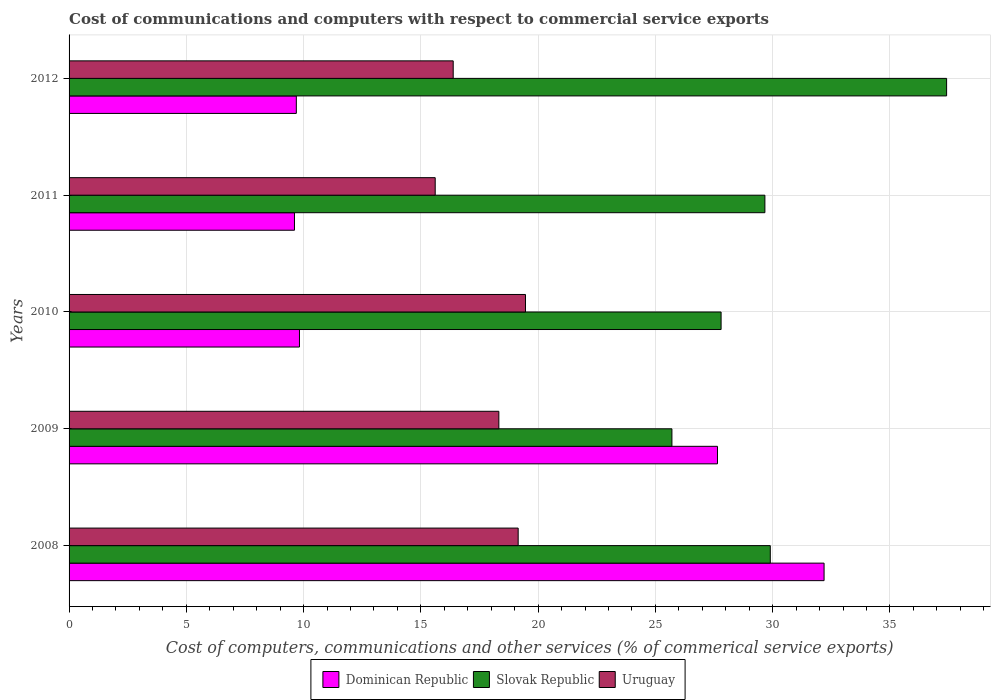In how many cases, is the number of bars for a given year not equal to the number of legend labels?
Ensure brevity in your answer.  0. What is the cost of communications and computers in Slovak Republic in 2009?
Your answer should be very brief. 25.71. Across all years, what is the maximum cost of communications and computers in Slovak Republic?
Give a very brief answer. 37.42. Across all years, what is the minimum cost of communications and computers in Dominican Republic?
Offer a terse response. 9.61. What is the total cost of communications and computers in Uruguay in the graph?
Offer a very short reply. 88.93. What is the difference between the cost of communications and computers in Slovak Republic in 2009 and that in 2011?
Give a very brief answer. -3.96. What is the difference between the cost of communications and computers in Dominican Republic in 2011 and the cost of communications and computers in Uruguay in 2012?
Provide a succinct answer. -6.77. What is the average cost of communications and computers in Dominican Republic per year?
Ensure brevity in your answer.  17.79. In the year 2012, what is the difference between the cost of communications and computers in Dominican Republic and cost of communications and computers in Uruguay?
Provide a succinct answer. -6.69. What is the ratio of the cost of communications and computers in Slovak Republic in 2009 to that in 2011?
Offer a very short reply. 0.87. What is the difference between the highest and the second highest cost of communications and computers in Dominican Republic?
Offer a terse response. 4.55. What is the difference between the highest and the lowest cost of communications and computers in Dominican Republic?
Offer a very short reply. 22.58. Is the sum of the cost of communications and computers in Dominican Republic in 2009 and 2010 greater than the maximum cost of communications and computers in Slovak Republic across all years?
Your answer should be very brief. Yes. What does the 3rd bar from the top in 2010 represents?
Keep it short and to the point. Dominican Republic. What does the 3rd bar from the bottom in 2008 represents?
Your answer should be very brief. Uruguay. Are all the bars in the graph horizontal?
Make the answer very short. Yes. How many years are there in the graph?
Your answer should be compact. 5. What is the difference between two consecutive major ticks on the X-axis?
Ensure brevity in your answer.  5. Are the values on the major ticks of X-axis written in scientific E-notation?
Offer a very short reply. No. Does the graph contain grids?
Give a very brief answer. Yes. How many legend labels are there?
Ensure brevity in your answer.  3. What is the title of the graph?
Give a very brief answer. Cost of communications and computers with respect to commercial service exports. Does "Brazil" appear as one of the legend labels in the graph?
Your answer should be compact. No. What is the label or title of the X-axis?
Offer a terse response. Cost of computers, communications and other services (% of commerical service exports). What is the Cost of computers, communications and other services (% of commerical service exports) of Dominican Republic in 2008?
Your answer should be compact. 32.19. What is the Cost of computers, communications and other services (% of commerical service exports) of Slovak Republic in 2008?
Offer a very short reply. 29.9. What is the Cost of computers, communications and other services (% of commerical service exports) in Uruguay in 2008?
Provide a succinct answer. 19.15. What is the Cost of computers, communications and other services (% of commerical service exports) of Dominican Republic in 2009?
Ensure brevity in your answer.  27.65. What is the Cost of computers, communications and other services (% of commerical service exports) of Slovak Republic in 2009?
Your answer should be very brief. 25.71. What is the Cost of computers, communications and other services (% of commerical service exports) in Uruguay in 2009?
Your answer should be compact. 18.33. What is the Cost of computers, communications and other services (% of commerical service exports) of Dominican Republic in 2010?
Your answer should be very brief. 9.82. What is the Cost of computers, communications and other services (% of commerical service exports) in Slovak Republic in 2010?
Provide a short and direct response. 27.8. What is the Cost of computers, communications and other services (% of commerical service exports) of Uruguay in 2010?
Ensure brevity in your answer.  19.46. What is the Cost of computers, communications and other services (% of commerical service exports) of Dominican Republic in 2011?
Make the answer very short. 9.61. What is the Cost of computers, communications and other services (% of commerical service exports) of Slovak Republic in 2011?
Offer a very short reply. 29.67. What is the Cost of computers, communications and other services (% of commerical service exports) of Uruguay in 2011?
Ensure brevity in your answer.  15.61. What is the Cost of computers, communications and other services (% of commerical service exports) in Dominican Republic in 2012?
Give a very brief answer. 9.69. What is the Cost of computers, communications and other services (% of commerical service exports) in Slovak Republic in 2012?
Give a very brief answer. 37.42. What is the Cost of computers, communications and other services (% of commerical service exports) of Uruguay in 2012?
Provide a short and direct response. 16.38. Across all years, what is the maximum Cost of computers, communications and other services (% of commerical service exports) in Dominican Republic?
Keep it short and to the point. 32.19. Across all years, what is the maximum Cost of computers, communications and other services (% of commerical service exports) in Slovak Republic?
Ensure brevity in your answer.  37.42. Across all years, what is the maximum Cost of computers, communications and other services (% of commerical service exports) of Uruguay?
Provide a short and direct response. 19.46. Across all years, what is the minimum Cost of computers, communications and other services (% of commerical service exports) of Dominican Republic?
Ensure brevity in your answer.  9.61. Across all years, what is the minimum Cost of computers, communications and other services (% of commerical service exports) of Slovak Republic?
Offer a very short reply. 25.71. Across all years, what is the minimum Cost of computers, communications and other services (% of commerical service exports) of Uruguay?
Offer a terse response. 15.61. What is the total Cost of computers, communications and other services (% of commerical service exports) in Dominican Republic in the graph?
Give a very brief answer. 88.97. What is the total Cost of computers, communications and other services (% of commerical service exports) of Slovak Republic in the graph?
Ensure brevity in your answer.  150.49. What is the total Cost of computers, communications and other services (% of commerical service exports) in Uruguay in the graph?
Keep it short and to the point. 88.93. What is the difference between the Cost of computers, communications and other services (% of commerical service exports) of Dominican Republic in 2008 and that in 2009?
Your answer should be very brief. 4.54. What is the difference between the Cost of computers, communications and other services (% of commerical service exports) of Slovak Republic in 2008 and that in 2009?
Ensure brevity in your answer.  4.19. What is the difference between the Cost of computers, communications and other services (% of commerical service exports) in Uruguay in 2008 and that in 2009?
Ensure brevity in your answer.  0.82. What is the difference between the Cost of computers, communications and other services (% of commerical service exports) of Dominican Republic in 2008 and that in 2010?
Offer a very short reply. 22.37. What is the difference between the Cost of computers, communications and other services (% of commerical service exports) of Slovak Republic in 2008 and that in 2010?
Your response must be concise. 2.1. What is the difference between the Cost of computers, communications and other services (% of commerical service exports) of Uruguay in 2008 and that in 2010?
Provide a succinct answer. -0.31. What is the difference between the Cost of computers, communications and other services (% of commerical service exports) of Dominican Republic in 2008 and that in 2011?
Your response must be concise. 22.58. What is the difference between the Cost of computers, communications and other services (% of commerical service exports) of Slovak Republic in 2008 and that in 2011?
Make the answer very short. 0.23. What is the difference between the Cost of computers, communications and other services (% of commerical service exports) in Uruguay in 2008 and that in 2011?
Make the answer very short. 3.54. What is the difference between the Cost of computers, communications and other services (% of commerical service exports) in Dominican Republic in 2008 and that in 2012?
Your answer should be compact. 22.5. What is the difference between the Cost of computers, communications and other services (% of commerical service exports) in Slovak Republic in 2008 and that in 2012?
Your answer should be compact. -7.52. What is the difference between the Cost of computers, communications and other services (% of commerical service exports) of Uruguay in 2008 and that in 2012?
Your answer should be very brief. 2.77. What is the difference between the Cost of computers, communications and other services (% of commerical service exports) in Dominican Republic in 2009 and that in 2010?
Your answer should be very brief. 17.82. What is the difference between the Cost of computers, communications and other services (% of commerical service exports) of Slovak Republic in 2009 and that in 2010?
Offer a very short reply. -2.1. What is the difference between the Cost of computers, communications and other services (% of commerical service exports) in Uruguay in 2009 and that in 2010?
Give a very brief answer. -1.14. What is the difference between the Cost of computers, communications and other services (% of commerical service exports) in Dominican Republic in 2009 and that in 2011?
Offer a terse response. 18.04. What is the difference between the Cost of computers, communications and other services (% of commerical service exports) of Slovak Republic in 2009 and that in 2011?
Give a very brief answer. -3.96. What is the difference between the Cost of computers, communications and other services (% of commerical service exports) of Uruguay in 2009 and that in 2011?
Your answer should be very brief. 2.71. What is the difference between the Cost of computers, communications and other services (% of commerical service exports) in Dominican Republic in 2009 and that in 2012?
Provide a short and direct response. 17.96. What is the difference between the Cost of computers, communications and other services (% of commerical service exports) in Slovak Republic in 2009 and that in 2012?
Offer a very short reply. -11.71. What is the difference between the Cost of computers, communications and other services (% of commerical service exports) in Uruguay in 2009 and that in 2012?
Offer a very short reply. 1.95. What is the difference between the Cost of computers, communications and other services (% of commerical service exports) of Dominican Republic in 2010 and that in 2011?
Your answer should be very brief. 0.21. What is the difference between the Cost of computers, communications and other services (% of commerical service exports) of Slovak Republic in 2010 and that in 2011?
Make the answer very short. -1.87. What is the difference between the Cost of computers, communications and other services (% of commerical service exports) in Uruguay in 2010 and that in 2011?
Your answer should be compact. 3.85. What is the difference between the Cost of computers, communications and other services (% of commerical service exports) of Dominican Republic in 2010 and that in 2012?
Keep it short and to the point. 0.13. What is the difference between the Cost of computers, communications and other services (% of commerical service exports) of Slovak Republic in 2010 and that in 2012?
Your answer should be very brief. -9.62. What is the difference between the Cost of computers, communications and other services (% of commerical service exports) of Uruguay in 2010 and that in 2012?
Your response must be concise. 3.08. What is the difference between the Cost of computers, communications and other services (% of commerical service exports) of Dominican Republic in 2011 and that in 2012?
Your response must be concise. -0.08. What is the difference between the Cost of computers, communications and other services (% of commerical service exports) in Slovak Republic in 2011 and that in 2012?
Make the answer very short. -7.75. What is the difference between the Cost of computers, communications and other services (% of commerical service exports) in Uruguay in 2011 and that in 2012?
Your answer should be very brief. -0.77. What is the difference between the Cost of computers, communications and other services (% of commerical service exports) in Dominican Republic in 2008 and the Cost of computers, communications and other services (% of commerical service exports) in Slovak Republic in 2009?
Offer a very short reply. 6.49. What is the difference between the Cost of computers, communications and other services (% of commerical service exports) in Dominican Republic in 2008 and the Cost of computers, communications and other services (% of commerical service exports) in Uruguay in 2009?
Make the answer very short. 13.87. What is the difference between the Cost of computers, communications and other services (% of commerical service exports) in Slovak Republic in 2008 and the Cost of computers, communications and other services (% of commerical service exports) in Uruguay in 2009?
Offer a very short reply. 11.57. What is the difference between the Cost of computers, communications and other services (% of commerical service exports) in Dominican Republic in 2008 and the Cost of computers, communications and other services (% of commerical service exports) in Slovak Republic in 2010?
Your response must be concise. 4.39. What is the difference between the Cost of computers, communications and other services (% of commerical service exports) of Dominican Republic in 2008 and the Cost of computers, communications and other services (% of commerical service exports) of Uruguay in 2010?
Offer a very short reply. 12.73. What is the difference between the Cost of computers, communications and other services (% of commerical service exports) in Slovak Republic in 2008 and the Cost of computers, communications and other services (% of commerical service exports) in Uruguay in 2010?
Make the answer very short. 10.44. What is the difference between the Cost of computers, communications and other services (% of commerical service exports) in Dominican Republic in 2008 and the Cost of computers, communications and other services (% of commerical service exports) in Slovak Republic in 2011?
Provide a short and direct response. 2.52. What is the difference between the Cost of computers, communications and other services (% of commerical service exports) of Dominican Republic in 2008 and the Cost of computers, communications and other services (% of commerical service exports) of Uruguay in 2011?
Keep it short and to the point. 16.58. What is the difference between the Cost of computers, communications and other services (% of commerical service exports) in Slovak Republic in 2008 and the Cost of computers, communications and other services (% of commerical service exports) in Uruguay in 2011?
Offer a very short reply. 14.29. What is the difference between the Cost of computers, communications and other services (% of commerical service exports) of Dominican Republic in 2008 and the Cost of computers, communications and other services (% of commerical service exports) of Slovak Republic in 2012?
Offer a terse response. -5.23. What is the difference between the Cost of computers, communications and other services (% of commerical service exports) in Dominican Republic in 2008 and the Cost of computers, communications and other services (% of commerical service exports) in Uruguay in 2012?
Make the answer very short. 15.81. What is the difference between the Cost of computers, communications and other services (% of commerical service exports) of Slovak Republic in 2008 and the Cost of computers, communications and other services (% of commerical service exports) of Uruguay in 2012?
Your response must be concise. 13.52. What is the difference between the Cost of computers, communications and other services (% of commerical service exports) in Dominican Republic in 2009 and the Cost of computers, communications and other services (% of commerical service exports) in Slovak Republic in 2010?
Provide a succinct answer. -0.15. What is the difference between the Cost of computers, communications and other services (% of commerical service exports) of Dominican Republic in 2009 and the Cost of computers, communications and other services (% of commerical service exports) of Uruguay in 2010?
Provide a succinct answer. 8.19. What is the difference between the Cost of computers, communications and other services (% of commerical service exports) in Slovak Republic in 2009 and the Cost of computers, communications and other services (% of commerical service exports) in Uruguay in 2010?
Provide a short and direct response. 6.24. What is the difference between the Cost of computers, communications and other services (% of commerical service exports) in Dominican Republic in 2009 and the Cost of computers, communications and other services (% of commerical service exports) in Slovak Republic in 2011?
Provide a succinct answer. -2.02. What is the difference between the Cost of computers, communications and other services (% of commerical service exports) of Dominican Republic in 2009 and the Cost of computers, communications and other services (% of commerical service exports) of Uruguay in 2011?
Keep it short and to the point. 12.04. What is the difference between the Cost of computers, communications and other services (% of commerical service exports) of Slovak Republic in 2009 and the Cost of computers, communications and other services (% of commerical service exports) of Uruguay in 2011?
Offer a terse response. 10.09. What is the difference between the Cost of computers, communications and other services (% of commerical service exports) in Dominican Republic in 2009 and the Cost of computers, communications and other services (% of commerical service exports) in Slovak Republic in 2012?
Provide a short and direct response. -9.77. What is the difference between the Cost of computers, communications and other services (% of commerical service exports) of Dominican Republic in 2009 and the Cost of computers, communications and other services (% of commerical service exports) of Uruguay in 2012?
Make the answer very short. 11.27. What is the difference between the Cost of computers, communications and other services (% of commerical service exports) of Slovak Republic in 2009 and the Cost of computers, communications and other services (% of commerical service exports) of Uruguay in 2012?
Your answer should be compact. 9.33. What is the difference between the Cost of computers, communications and other services (% of commerical service exports) of Dominican Republic in 2010 and the Cost of computers, communications and other services (% of commerical service exports) of Slovak Republic in 2011?
Keep it short and to the point. -19.85. What is the difference between the Cost of computers, communications and other services (% of commerical service exports) in Dominican Republic in 2010 and the Cost of computers, communications and other services (% of commerical service exports) in Uruguay in 2011?
Ensure brevity in your answer.  -5.79. What is the difference between the Cost of computers, communications and other services (% of commerical service exports) of Slovak Republic in 2010 and the Cost of computers, communications and other services (% of commerical service exports) of Uruguay in 2011?
Offer a terse response. 12.19. What is the difference between the Cost of computers, communications and other services (% of commerical service exports) of Dominican Republic in 2010 and the Cost of computers, communications and other services (% of commerical service exports) of Slovak Republic in 2012?
Offer a terse response. -27.59. What is the difference between the Cost of computers, communications and other services (% of commerical service exports) of Dominican Republic in 2010 and the Cost of computers, communications and other services (% of commerical service exports) of Uruguay in 2012?
Ensure brevity in your answer.  -6.55. What is the difference between the Cost of computers, communications and other services (% of commerical service exports) of Slovak Republic in 2010 and the Cost of computers, communications and other services (% of commerical service exports) of Uruguay in 2012?
Ensure brevity in your answer.  11.42. What is the difference between the Cost of computers, communications and other services (% of commerical service exports) in Dominican Republic in 2011 and the Cost of computers, communications and other services (% of commerical service exports) in Slovak Republic in 2012?
Offer a very short reply. -27.81. What is the difference between the Cost of computers, communications and other services (% of commerical service exports) in Dominican Republic in 2011 and the Cost of computers, communications and other services (% of commerical service exports) in Uruguay in 2012?
Your response must be concise. -6.77. What is the difference between the Cost of computers, communications and other services (% of commerical service exports) in Slovak Republic in 2011 and the Cost of computers, communications and other services (% of commerical service exports) in Uruguay in 2012?
Your answer should be compact. 13.29. What is the average Cost of computers, communications and other services (% of commerical service exports) in Dominican Republic per year?
Your answer should be very brief. 17.79. What is the average Cost of computers, communications and other services (% of commerical service exports) of Slovak Republic per year?
Make the answer very short. 30.1. What is the average Cost of computers, communications and other services (% of commerical service exports) in Uruguay per year?
Provide a short and direct response. 17.79. In the year 2008, what is the difference between the Cost of computers, communications and other services (% of commerical service exports) in Dominican Republic and Cost of computers, communications and other services (% of commerical service exports) in Slovak Republic?
Your answer should be very brief. 2.29. In the year 2008, what is the difference between the Cost of computers, communications and other services (% of commerical service exports) of Dominican Republic and Cost of computers, communications and other services (% of commerical service exports) of Uruguay?
Ensure brevity in your answer.  13.04. In the year 2008, what is the difference between the Cost of computers, communications and other services (% of commerical service exports) of Slovak Republic and Cost of computers, communications and other services (% of commerical service exports) of Uruguay?
Offer a terse response. 10.75. In the year 2009, what is the difference between the Cost of computers, communications and other services (% of commerical service exports) of Dominican Republic and Cost of computers, communications and other services (% of commerical service exports) of Slovak Republic?
Your answer should be compact. 1.94. In the year 2009, what is the difference between the Cost of computers, communications and other services (% of commerical service exports) in Dominican Republic and Cost of computers, communications and other services (% of commerical service exports) in Uruguay?
Offer a very short reply. 9.32. In the year 2009, what is the difference between the Cost of computers, communications and other services (% of commerical service exports) in Slovak Republic and Cost of computers, communications and other services (% of commerical service exports) in Uruguay?
Your response must be concise. 7.38. In the year 2010, what is the difference between the Cost of computers, communications and other services (% of commerical service exports) in Dominican Republic and Cost of computers, communications and other services (% of commerical service exports) in Slovak Republic?
Offer a very short reply. -17.98. In the year 2010, what is the difference between the Cost of computers, communications and other services (% of commerical service exports) of Dominican Republic and Cost of computers, communications and other services (% of commerical service exports) of Uruguay?
Provide a short and direct response. -9.64. In the year 2010, what is the difference between the Cost of computers, communications and other services (% of commerical service exports) in Slovak Republic and Cost of computers, communications and other services (% of commerical service exports) in Uruguay?
Your answer should be very brief. 8.34. In the year 2011, what is the difference between the Cost of computers, communications and other services (% of commerical service exports) in Dominican Republic and Cost of computers, communications and other services (% of commerical service exports) in Slovak Republic?
Provide a short and direct response. -20.06. In the year 2011, what is the difference between the Cost of computers, communications and other services (% of commerical service exports) in Dominican Republic and Cost of computers, communications and other services (% of commerical service exports) in Uruguay?
Offer a terse response. -6. In the year 2011, what is the difference between the Cost of computers, communications and other services (% of commerical service exports) of Slovak Republic and Cost of computers, communications and other services (% of commerical service exports) of Uruguay?
Your answer should be compact. 14.06. In the year 2012, what is the difference between the Cost of computers, communications and other services (% of commerical service exports) in Dominican Republic and Cost of computers, communications and other services (% of commerical service exports) in Slovak Republic?
Offer a terse response. -27.73. In the year 2012, what is the difference between the Cost of computers, communications and other services (% of commerical service exports) of Dominican Republic and Cost of computers, communications and other services (% of commerical service exports) of Uruguay?
Make the answer very short. -6.69. In the year 2012, what is the difference between the Cost of computers, communications and other services (% of commerical service exports) in Slovak Republic and Cost of computers, communications and other services (% of commerical service exports) in Uruguay?
Offer a terse response. 21.04. What is the ratio of the Cost of computers, communications and other services (% of commerical service exports) in Dominican Republic in 2008 to that in 2009?
Provide a short and direct response. 1.16. What is the ratio of the Cost of computers, communications and other services (% of commerical service exports) of Slovak Republic in 2008 to that in 2009?
Ensure brevity in your answer.  1.16. What is the ratio of the Cost of computers, communications and other services (% of commerical service exports) in Uruguay in 2008 to that in 2009?
Offer a terse response. 1.04. What is the ratio of the Cost of computers, communications and other services (% of commerical service exports) of Dominican Republic in 2008 to that in 2010?
Ensure brevity in your answer.  3.28. What is the ratio of the Cost of computers, communications and other services (% of commerical service exports) in Slovak Republic in 2008 to that in 2010?
Offer a terse response. 1.08. What is the ratio of the Cost of computers, communications and other services (% of commerical service exports) of Uruguay in 2008 to that in 2010?
Provide a succinct answer. 0.98. What is the ratio of the Cost of computers, communications and other services (% of commerical service exports) in Dominican Republic in 2008 to that in 2011?
Offer a very short reply. 3.35. What is the ratio of the Cost of computers, communications and other services (% of commerical service exports) in Uruguay in 2008 to that in 2011?
Keep it short and to the point. 1.23. What is the ratio of the Cost of computers, communications and other services (% of commerical service exports) in Dominican Republic in 2008 to that in 2012?
Give a very brief answer. 3.32. What is the ratio of the Cost of computers, communications and other services (% of commerical service exports) in Slovak Republic in 2008 to that in 2012?
Keep it short and to the point. 0.8. What is the ratio of the Cost of computers, communications and other services (% of commerical service exports) in Uruguay in 2008 to that in 2012?
Your answer should be very brief. 1.17. What is the ratio of the Cost of computers, communications and other services (% of commerical service exports) of Dominican Republic in 2009 to that in 2010?
Offer a terse response. 2.81. What is the ratio of the Cost of computers, communications and other services (% of commerical service exports) of Slovak Republic in 2009 to that in 2010?
Your answer should be compact. 0.92. What is the ratio of the Cost of computers, communications and other services (% of commerical service exports) of Uruguay in 2009 to that in 2010?
Your response must be concise. 0.94. What is the ratio of the Cost of computers, communications and other services (% of commerical service exports) of Dominican Republic in 2009 to that in 2011?
Give a very brief answer. 2.88. What is the ratio of the Cost of computers, communications and other services (% of commerical service exports) of Slovak Republic in 2009 to that in 2011?
Give a very brief answer. 0.87. What is the ratio of the Cost of computers, communications and other services (% of commerical service exports) in Uruguay in 2009 to that in 2011?
Keep it short and to the point. 1.17. What is the ratio of the Cost of computers, communications and other services (% of commerical service exports) of Dominican Republic in 2009 to that in 2012?
Keep it short and to the point. 2.85. What is the ratio of the Cost of computers, communications and other services (% of commerical service exports) of Slovak Republic in 2009 to that in 2012?
Offer a very short reply. 0.69. What is the ratio of the Cost of computers, communications and other services (% of commerical service exports) in Uruguay in 2009 to that in 2012?
Keep it short and to the point. 1.12. What is the ratio of the Cost of computers, communications and other services (% of commerical service exports) in Dominican Republic in 2010 to that in 2011?
Provide a short and direct response. 1.02. What is the ratio of the Cost of computers, communications and other services (% of commerical service exports) in Slovak Republic in 2010 to that in 2011?
Provide a short and direct response. 0.94. What is the ratio of the Cost of computers, communications and other services (% of commerical service exports) of Uruguay in 2010 to that in 2011?
Make the answer very short. 1.25. What is the ratio of the Cost of computers, communications and other services (% of commerical service exports) of Dominican Republic in 2010 to that in 2012?
Ensure brevity in your answer.  1.01. What is the ratio of the Cost of computers, communications and other services (% of commerical service exports) in Slovak Republic in 2010 to that in 2012?
Ensure brevity in your answer.  0.74. What is the ratio of the Cost of computers, communications and other services (% of commerical service exports) of Uruguay in 2010 to that in 2012?
Your answer should be very brief. 1.19. What is the ratio of the Cost of computers, communications and other services (% of commerical service exports) of Dominican Republic in 2011 to that in 2012?
Offer a terse response. 0.99. What is the ratio of the Cost of computers, communications and other services (% of commerical service exports) in Slovak Republic in 2011 to that in 2012?
Provide a short and direct response. 0.79. What is the ratio of the Cost of computers, communications and other services (% of commerical service exports) in Uruguay in 2011 to that in 2012?
Provide a succinct answer. 0.95. What is the difference between the highest and the second highest Cost of computers, communications and other services (% of commerical service exports) of Dominican Republic?
Your response must be concise. 4.54. What is the difference between the highest and the second highest Cost of computers, communications and other services (% of commerical service exports) of Slovak Republic?
Your response must be concise. 7.52. What is the difference between the highest and the second highest Cost of computers, communications and other services (% of commerical service exports) in Uruguay?
Provide a succinct answer. 0.31. What is the difference between the highest and the lowest Cost of computers, communications and other services (% of commerical service exports) in Dominican Republic?
Provide a short and direct response. 22.58. What is the difference between the highest and the lowest Cost of computers, communications and other services (% of commerical service exports) of Slovak Republic?
Provide a succinct answer. 11.71. What is the difference between the highest and the lowest Cost of computers, communications and other services (% of commerical service exports) of Uruguay?
Offer a very short reply. 3.85. 